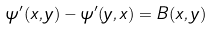<formula> <loc_0><loc_0><loc_500><loc_500>\psi ^ { \prime } ( x , y ) - \psi ^ { \prime } ( y , x ) = B ( x , y )</formula> 